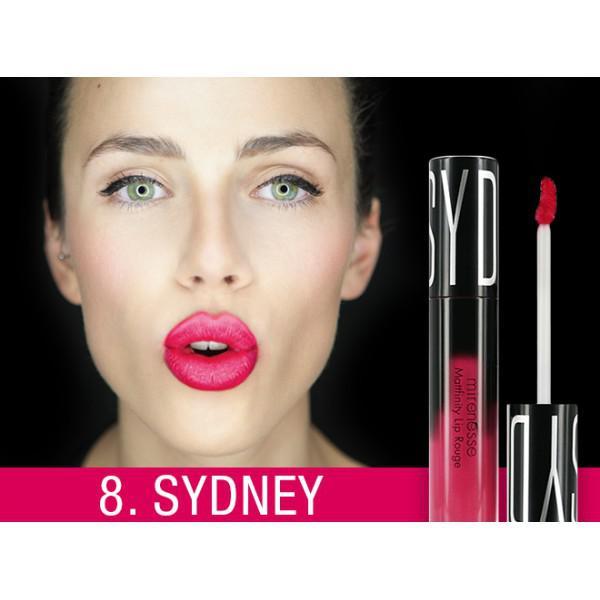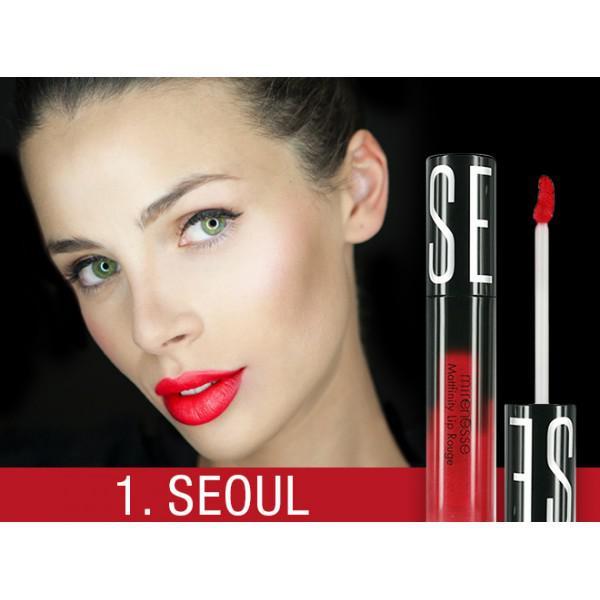The first image is the image on the left, the second image is the image on the right. Analyze the images presented: Is the assertion "There is exactly one hand visible in one of the images" valid? Answer yes or no. No. 